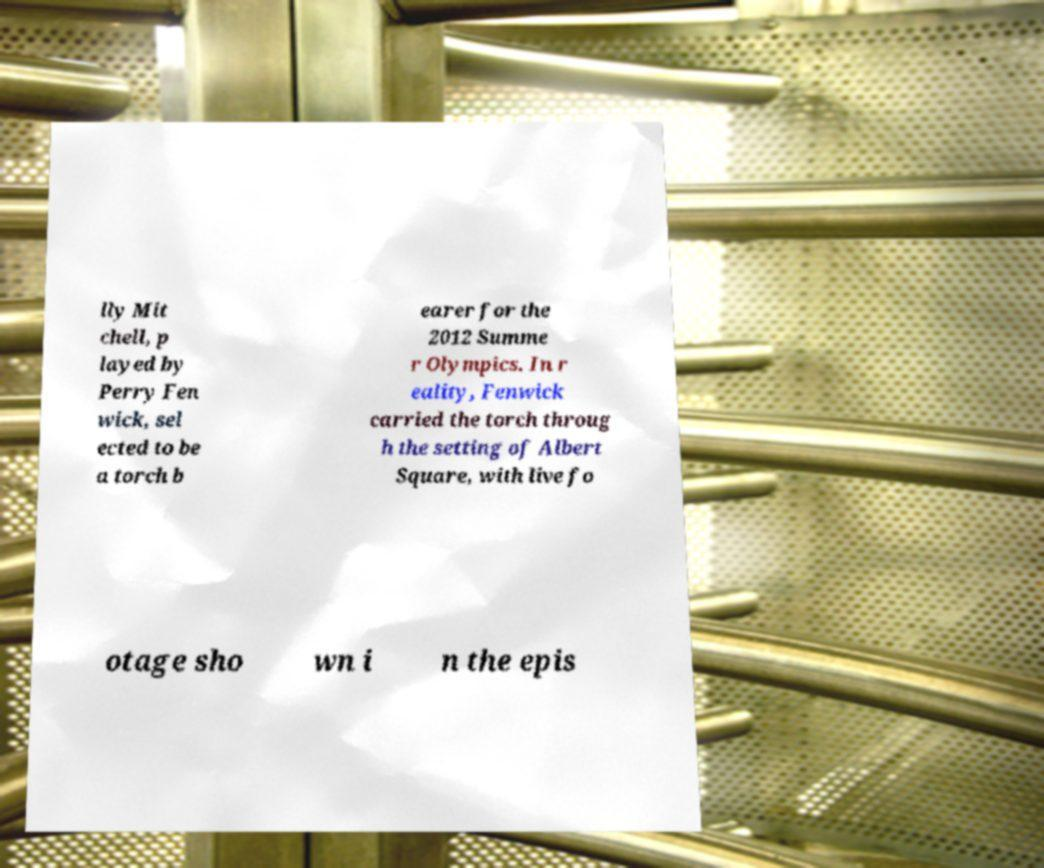Can you read and provide the text displayed in the image?This photo seems to have some interesting text. Can you extract and type it out for me? lly Mit chell, p layed by Perry Fen wick, sel ected to be a torch b earer for the 2012 Summe r Olympics. In r eality, Fenwick carried the torch throug h the setting of Albert Square, with live fo otage sho wn i n the epis 